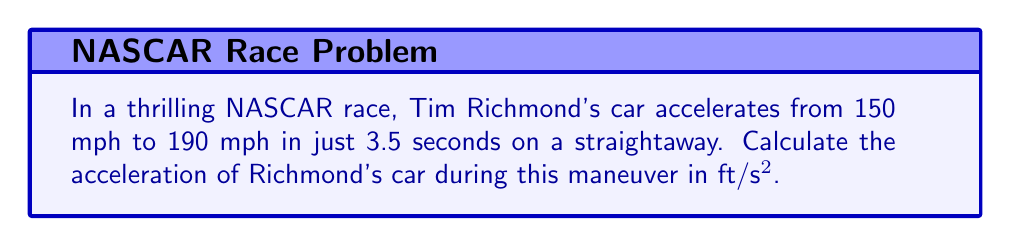Show me your answer to this math problem. To solve this problem, we'll follow these steps:

1) Convert speeds from mph to ft/s:
   Initial velocity (v₀): 150 mph = 150 * (5280 ft / 3600 s) = 220 ft/s
   Final velocity (v): 190 mph = 190 * (5280 ft / 3600 s) = 278.67 ft/s

2) Identify the time interval (t):
   t = 3.5 seconds

3) Use the acceleration formula:
   $$a = \frac{v - v_0}{t}$$

4) Plug in the values:
   $$a = \frac{278.67 \text{ ft/s} - 220 \text{ ft/s}}{3.5 \text{ s}}$$

5) Calculate:
   $$a = \frac{58.67 \text{ ft/s}}{3.5 \text{ s}} = 16.76 \text{ ft/s²}$$

Therefore, Tim Richmond's car accelerates at approximately 16.76 ft/s².
Answer: 16.76 ft/s² 